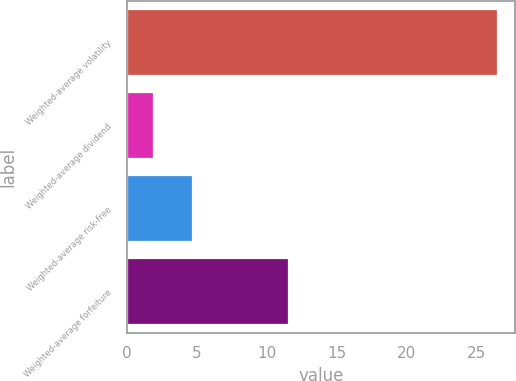Convert chart. <chart><loc_0><loc_0><loc_500><loc_500><bar_chart><fcel>Weighted-average volatility<fcel>Weighted-average dividend<fcel>Weighted-average risk-free<fcel>Weighted-average forfeiture<nl><fcel>26.45<fcel>1.89<fcel>4.68<fcel>11.5<nl></chart> 